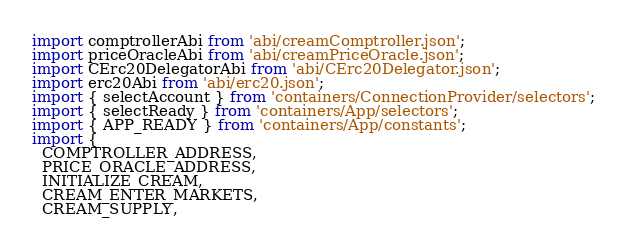Convert code to text. <code><loc_0><loc_0><loc_500><loc_500><_JavaScript_>import comptrollerAbi from 'abi/creamComptroller.json';
import priceOracleAbi from 'abi/creamPriceOracle.json';
import CErc20DelegatorAbi from 'abi/CErc20Delegator.json';
import erc20Abi from 'abi/erc20.json';
import { selectAccount } from 'containers/ConnectionProvider/selectors';
import { selectReady } from 'containers/App/selectors';
import { APP_READY } from 'containers/App/constants';
import {
  COMPTROLLER_ADDRESS,
  PRICE_ORACLE_ADDRESS,
  INITIALIZE_CREAM,
  CREAM_ENTER_MARKETS,
  CREAM_SUPPLY,</code> 